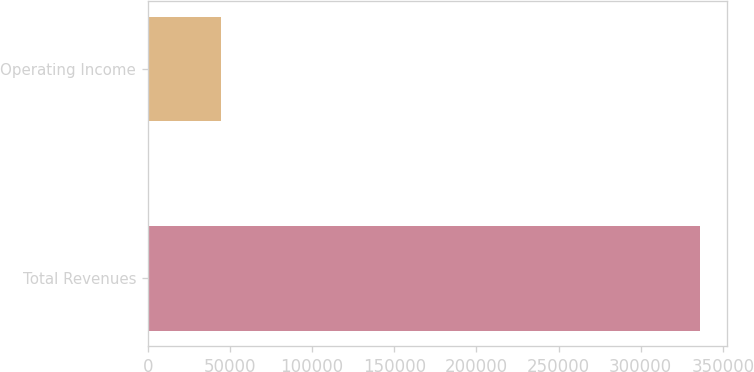<chart> <loc_0><loc_0><loc_500><loc_500><bar_chart><fcel>Total Revenues<fcel>Operating Income<nl><fcel>335795<fcel>44227<nl></chart> 